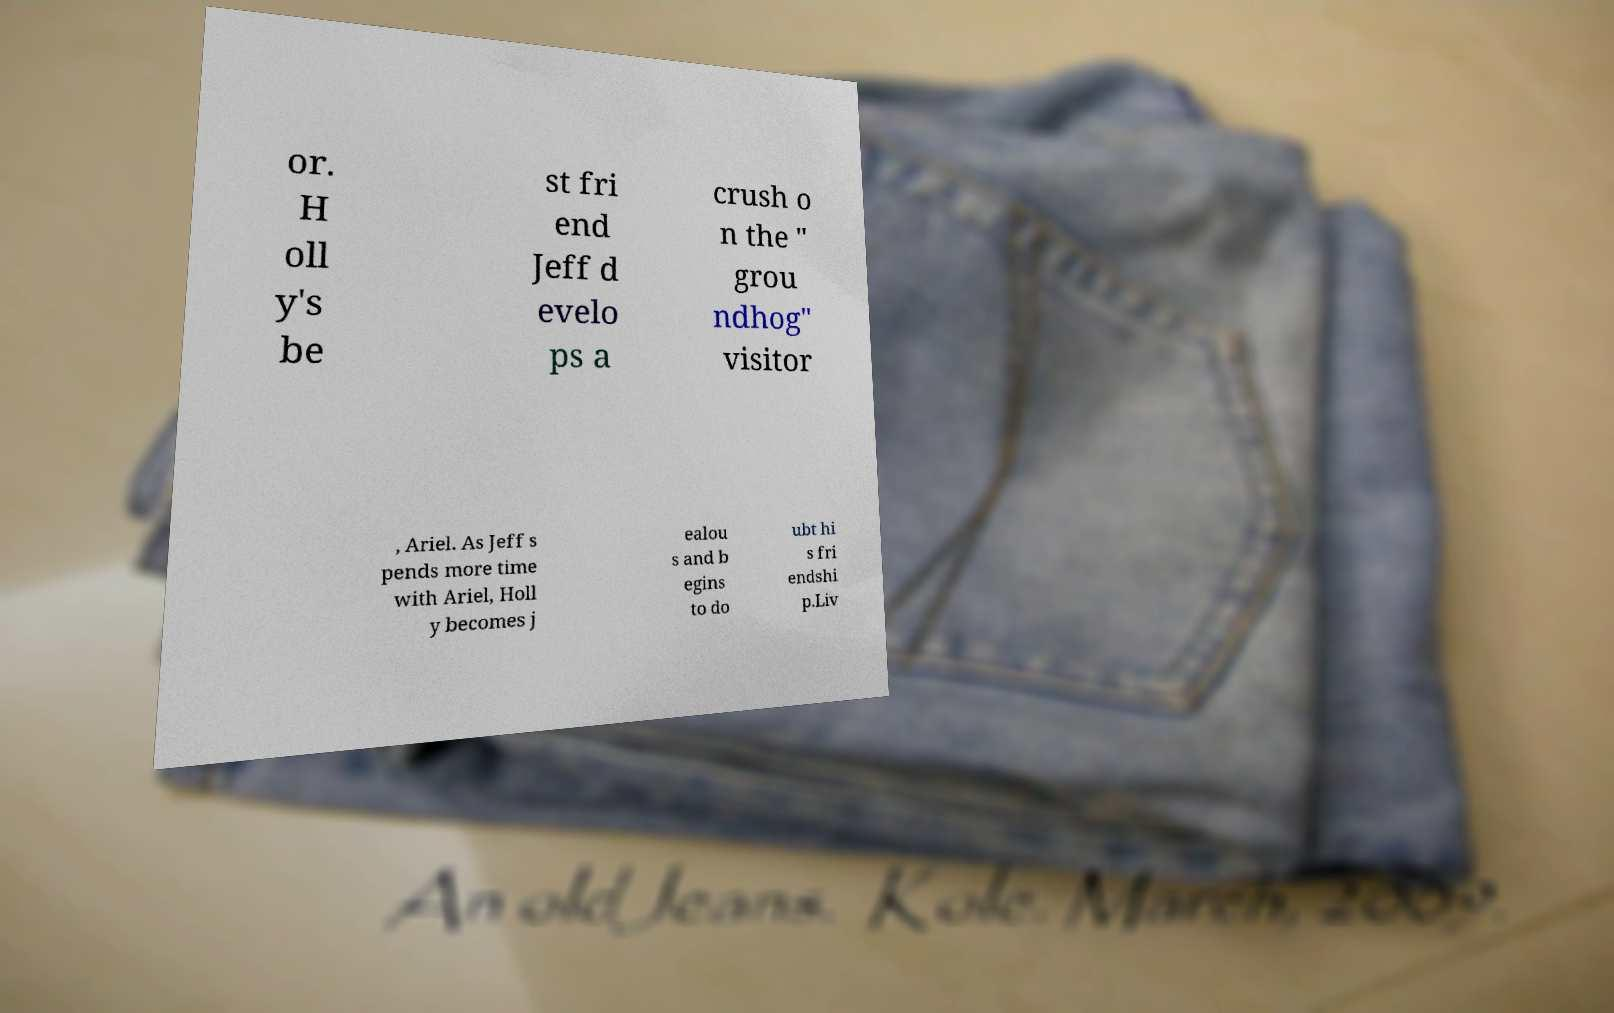I need the written content from this picture converted into text. Can you do that? or. H oll y's be st fri end Jeff d evelo ps a crush o n the " grou ndhog" visitor , Ariel. As Jeff s pends more time with Ariel, Holl y becomes j ealou s and b egins to do ubt hi s fri endshi p.Liv 